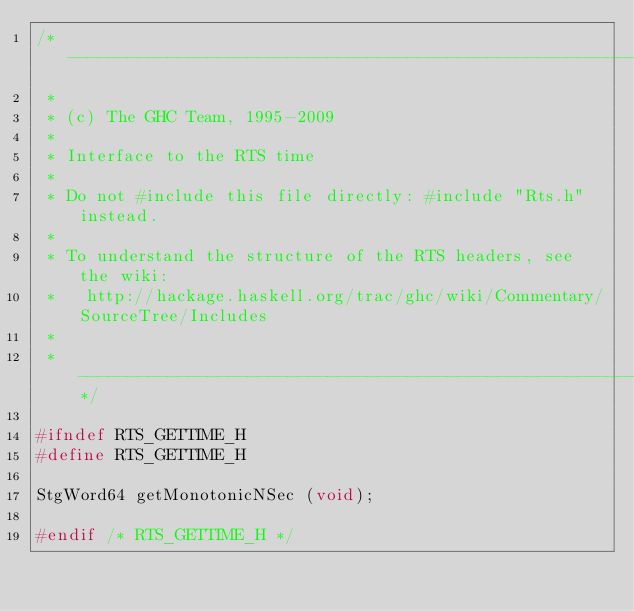<code> <loc_0><loc_0><loc_500><loc_500><_C_>/* -----------------------------------------------------------------------------
 *
 * (c) The GHC Team, 1995-2009
 *
 * Interface to the RTS time
 *
 * Do not #include this file directly: #include "Rts.h" instead.
 *
 * To understand the structure of the RTS headers, see the wiki:
 *   http://hackage.haskell.org/trac/ghc/wiki/Commentary/SourceTree/Includes
 *
 * ---------------------------------------------------------------------------*/

#ifndef RTS_GETTIME_H
#define RTS_GETTIME_H

StgWord64 getMonotonicNSec (void);

#endif /* RTS_GETTIME_H */
</code> 